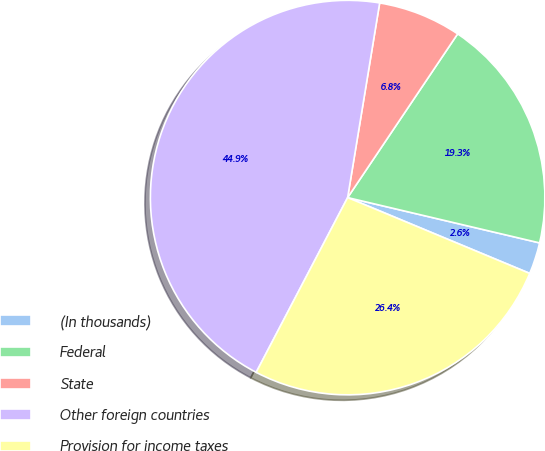Convert chart. <chart><loc_0><loc_0><loc_500><loc_500><pie_chart><fcel>(In thousands)<fcel>Federal<fcel>State<fcel>Other foreign countries<fcel>Provision for income taxes<nl><fcel>2.59%<fcel>19.27%<fcel>6.82%<fcel>44.92%<fcel>26.39%<nl></chart> 